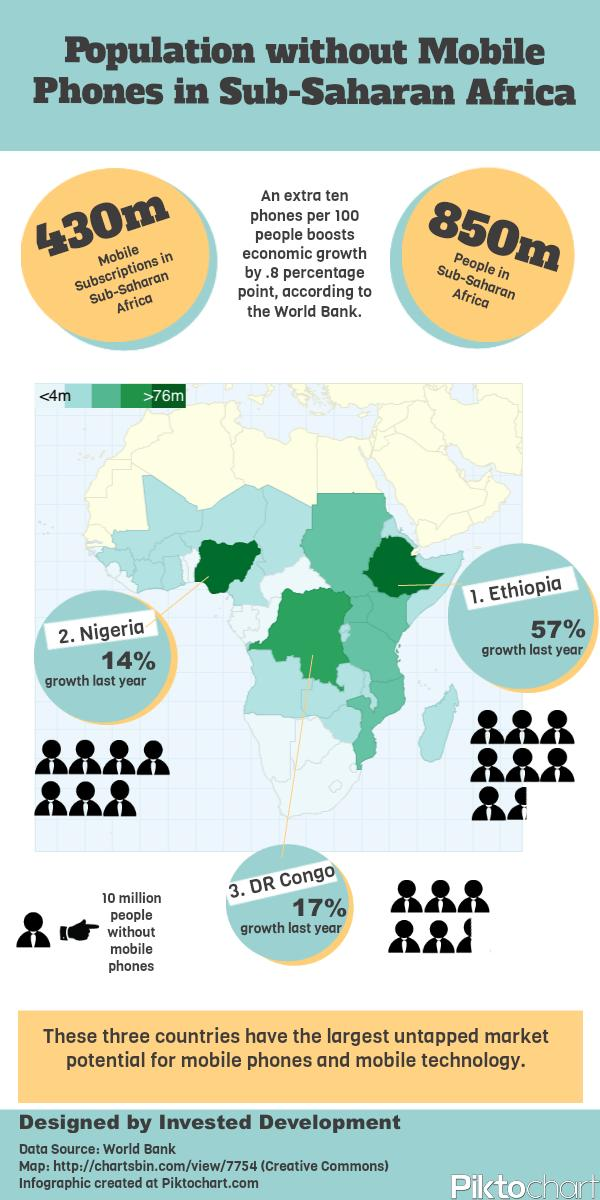Identify some key points in this picture. There are approximately 420 million individuals globally who do not have access to mobile phone subscriptions. The percentage growth of Nigeria and the Democratic Republic of the Congo taken together is 31%. The combined percentage growth of Ethiopia and the Democratic Republic of Congo is 74%. The percentage growth of Ethiopia and Nigeria, taken together, is 71%. 